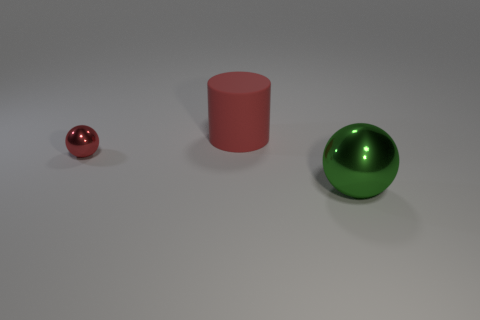What is the material of the red thing that is the same shape as the large green object?
Ensure brevity in your answer.  Metal. There is a red metal object; how many red objects are on the right side of it?
Provide a short and direct response. 1. The small thing that is the same color as the cylinder is what shape?
Provide a succinct answer. Sphere. Is there a small thing that is on the left side of the red object that is behind the red thing on the left side of the big red object?
Ensure brevity in your answer.  Yes. Does the red cylinder have the same size as the red metallic ball?
Provide a succinct answer. No. Are there an equal number of big cylinders that are behind the small red metal ball and large things in front of the large matte cylinder?
Offer a terse response. Yes. There is a red object that is to the left of the red cylinder; what is its shape?
Keep it short and to the point. Sphere. There is another object that is the same size as the rubber thing; what shape is it?
Ensure brevity in your answer.  Sphere. There is a ball left of the red thing behind the metal ball behind the large green metallic ball; what color is it?
Keep it short and to the point. Red. Does the tiny red object have the same shape as the big green shiny thing?
Give a very brief answer. Yes. 